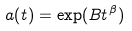<formula> <loc_0><loc_0><loc_500><loc_500>a ( t ) = \exp ( B t ^ { \beta } )</formula> 